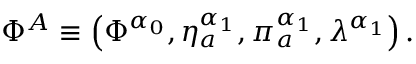<formula> <loc_0><loc_0><loc_500><loc_500>\Phi ^ { A } \equiv \left ( \Phi ^ { \alpha _ { 0 } } , \eta _ { a } ^ { \alpha _ { 1 } } , \pi _ { a } ^ { \alpha _ { 1 } } , \lambda ^ { \alpha _ { 1 } } \right ) .</formula> 